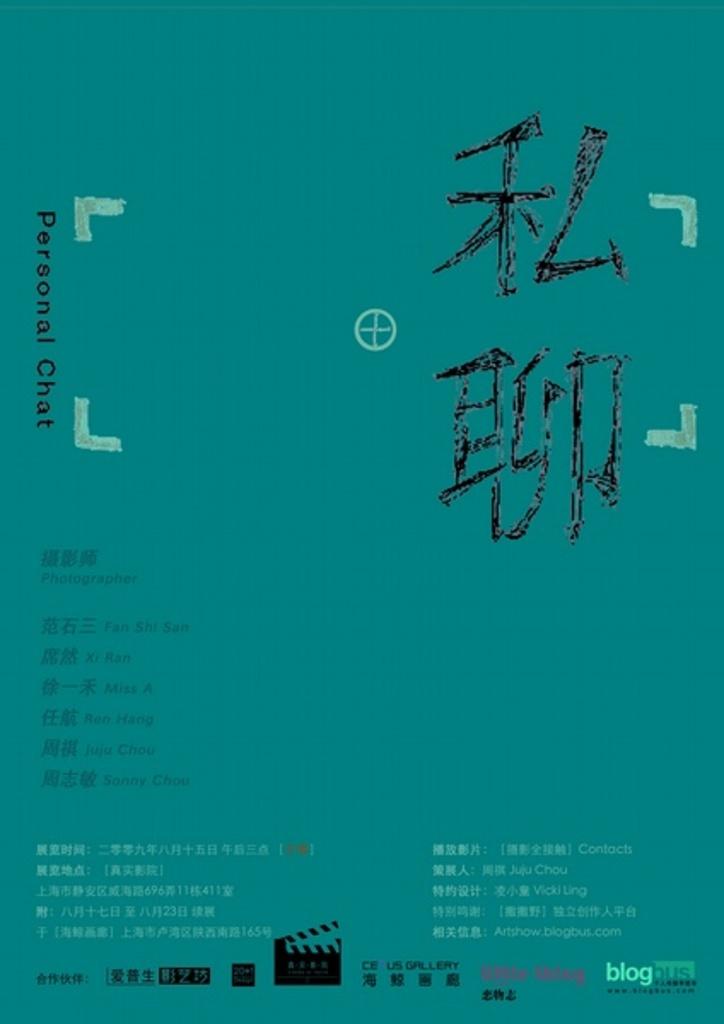What type of card is this?
Keep it short and to the point. Personal chat. What kind of chat?
Your response must be concise. Personal. 